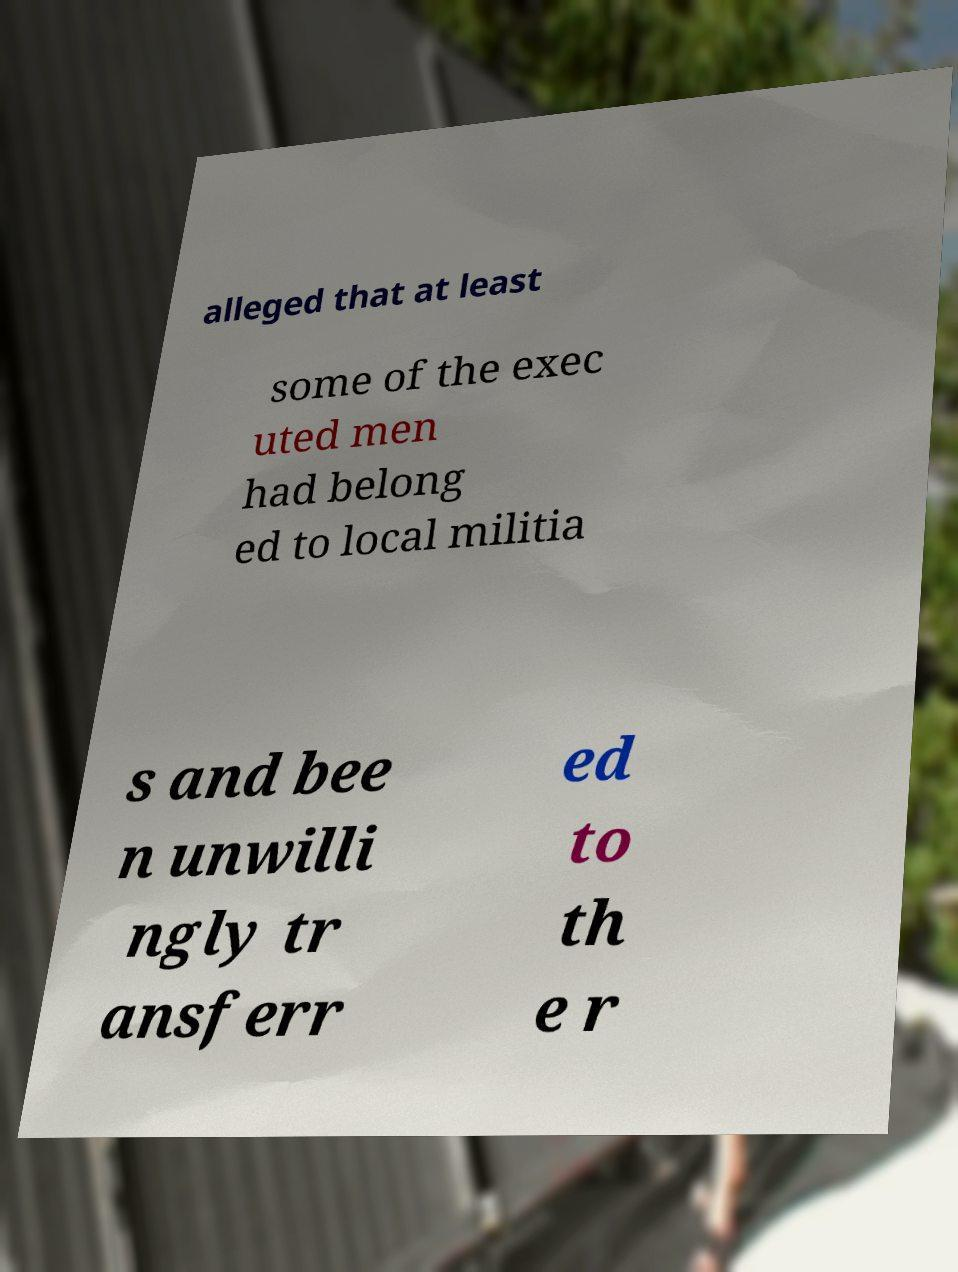Please read and relay the text visible in this image. What does it say? alleged that at least some of the exec uted men had belong ed to local militia s and bee n unwilli ngly tr ansferr ed to th e r 